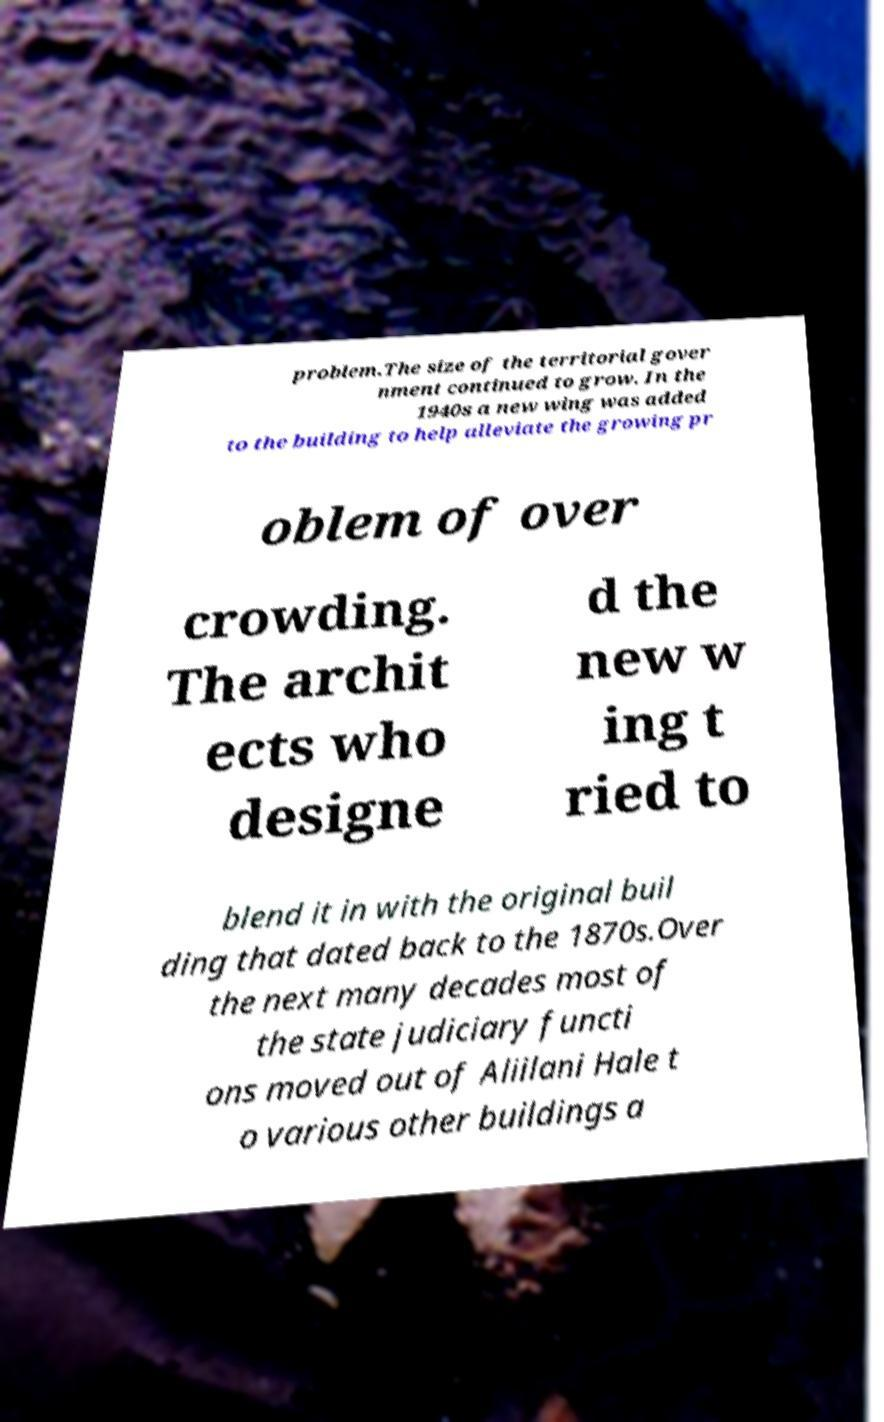Can you read and provide the text displayed in the image?This photo seems to have some interesting text. Can you extract and type it out for me? problem.The size of the territorial gover nment continued to grow. In the 1940s a new wing was added to the building to help alleviate the growing pr oblem of over crowding. The archit ects who designe d the new w ing t ried to blend it in with the original buil ding that dated back to the 1870s.Over the next many decades most of the state judiciary functi ons moved out of Aliilani Hale t o various other buildings a 